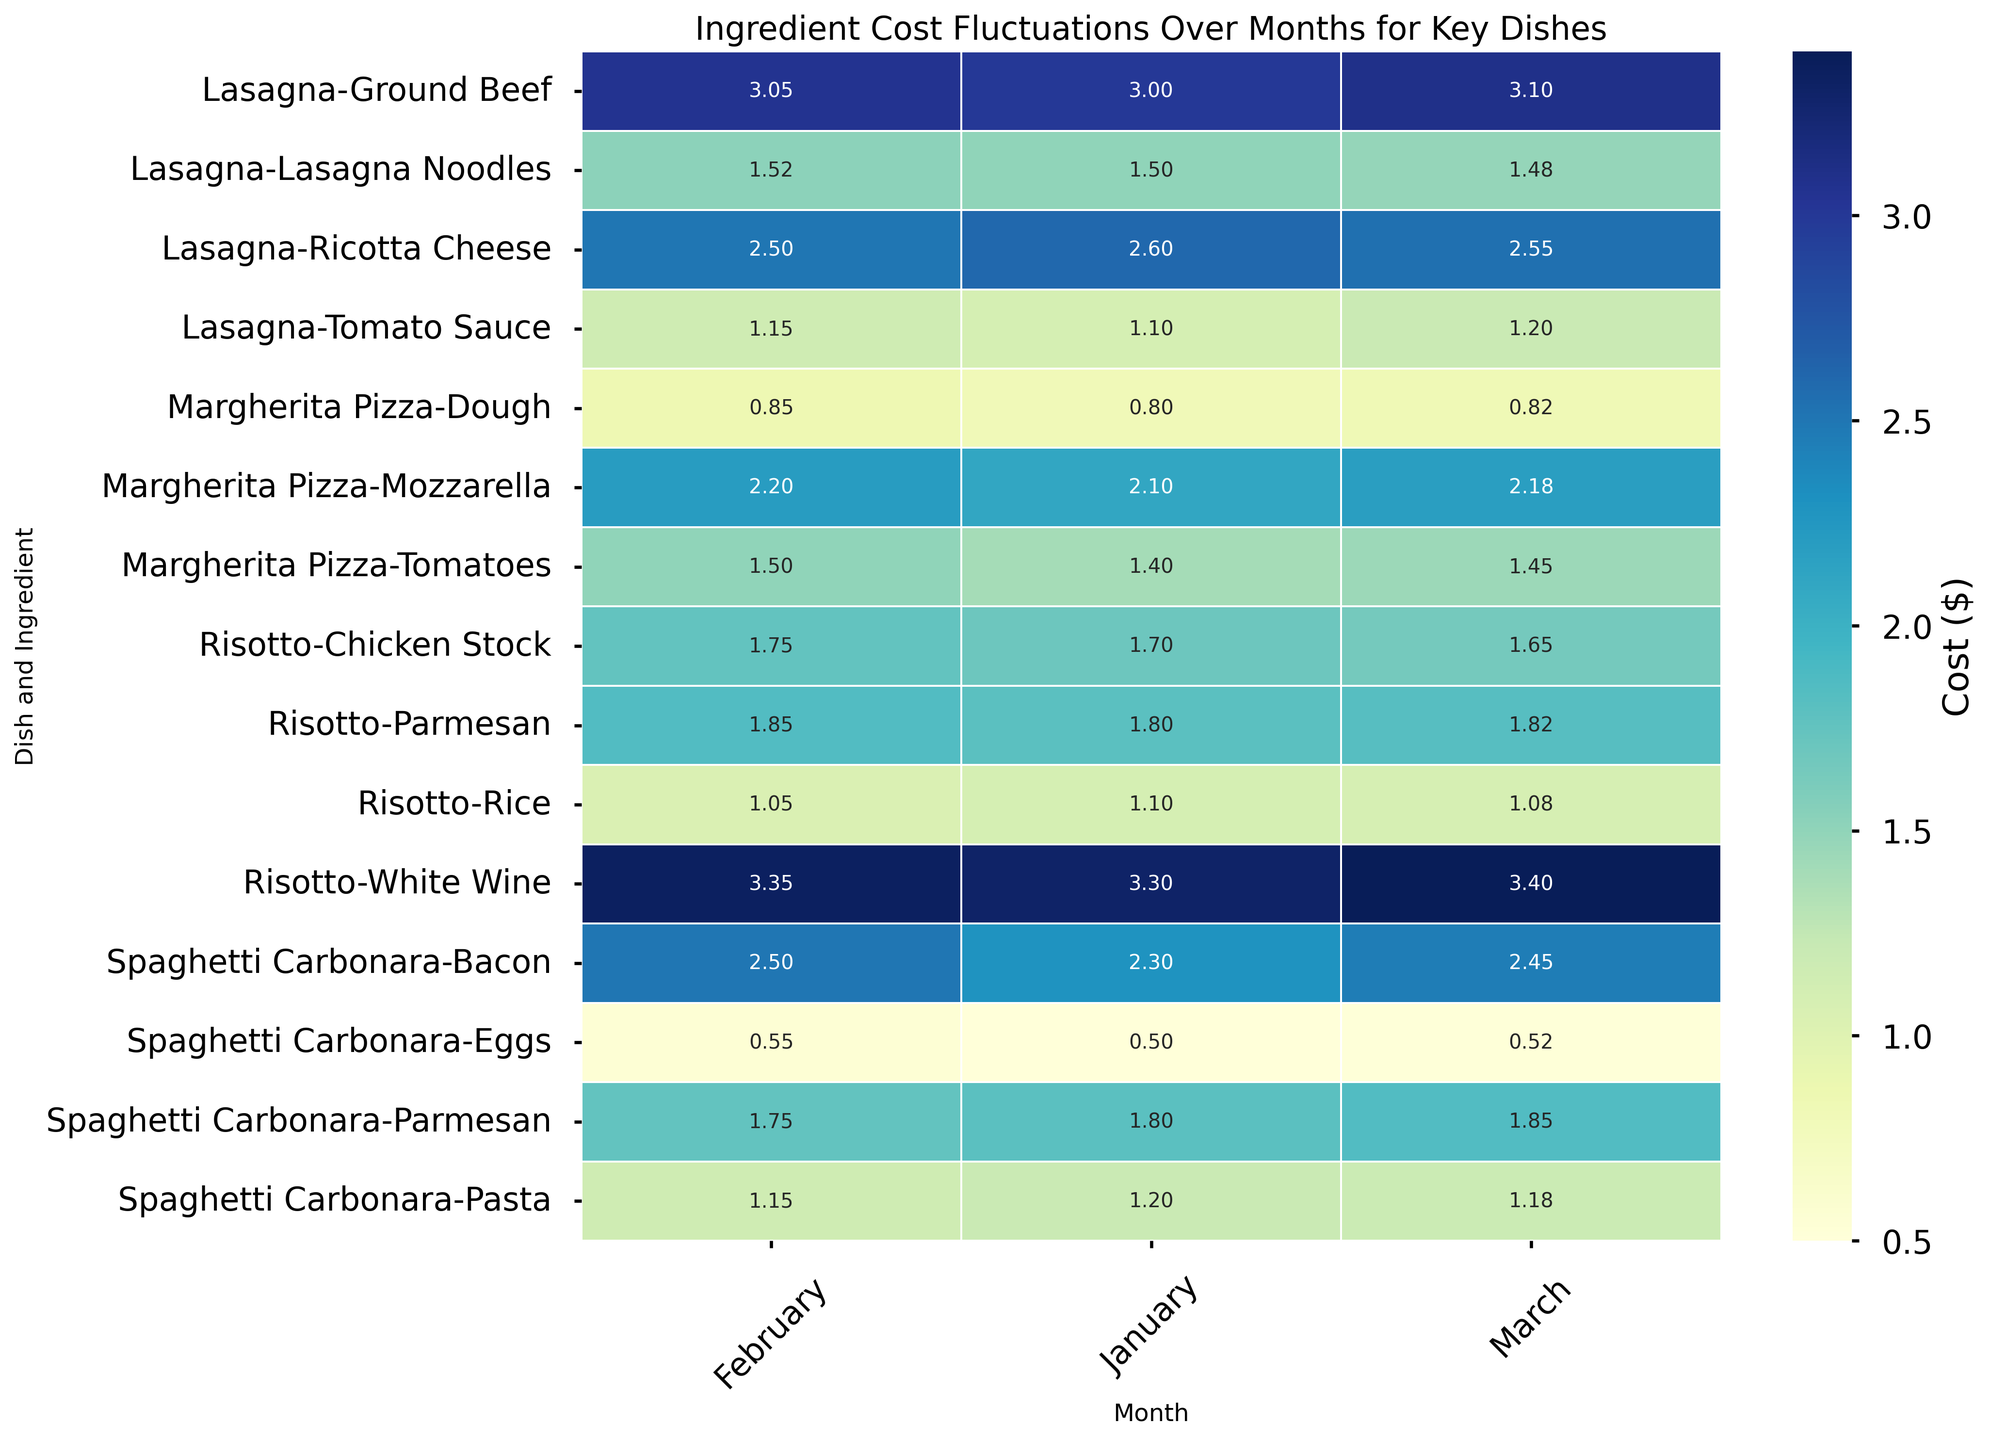What is the average cost of Bacon in Spaghetti Carbonara over the three months? To find the average cost of Bacon in Spaghetti Carbonara, first, look at the cost of Bacon in January, February, and March, which are 2.3, 2.5, and 2.45 respectively. Sum these costs: 2.3 + 2.5 + 2.45 = 7.25. Then, divide by 3 to find the average: 7.25 / 3 = 2.42.
Answer: 2.42 Which month had the highest cost for Ground Beef in Lasagna and what was the cost? Compare the cost of Ground Beef in Lasagna for the three months: 3.0 in January, 3.05 in February, and 3.1 in March. The highest cost is in March with 3.1.
Answer: March, 3.1 Did the cost of Parmesan in Spaghetti Carbonara increase or decrease from January to February? Identify the cost of Parmesan in January and February, which are 1.8 and 1.75 respectively. Since 1.75 is less than 1.8, the cost decreased.
Answer: Decrease What is the total cost of all ingredients for Risotto in February? Sum the costs of all the ingredients for Risotto in February: Rice (1.05), Chicken Stock (1.75), Parmesan (1.85), and White Wine (3.35). Therefore, the total cost is 1.05 + 1.75 + 1.85 + 3.35 = 8.00.
Answer: 8.00 Which ingredient in Margherita Pizza had the greatest fluctuation in cost over the three months? Examine the cost of each ingredient in Margherita Pizza over the three months: Dough (0.8, 0.85, 0.82), Tomatoes (1.4, 1.5, 1.45), and Mozzarella (2.1, 2.2, 2.18). Calculate the range (highest cost - lowest cost) for each: Dough (0.85 - 0.8 = 0.05), Tomatoes (1.5 - 1.4 = 0.1), and Mozzarella (2.2 - 2.1 = 0.1). Both Tomatoes and Mozzarella have the greatest fluctuation of 0.1.
Answer: Tomatoes and Mozzarella Did the cost of Lasagna Noodles in Lasagna decrease or increase from February to March? Identify the cost of Lasagna Noodles in February and March, which are 1.52 and 1.48 respectively. Since 1.48 is less than 1.52, the cost decreased.
Answer: Decrease What is the difference in cost between Rice in Risotto and Dough in Margherita Pizza for January? Identify the cost of Rice in Risotto for January (1.1) and Dough in Margherita Pizza for January (0.8). Subtract these values: 1.1 - 0.8 = 0.3.
Answer: 0.3 Which dish had the lowest total ingredient costs for January? Calculate the total ingredient costs for each dish in January: Spaghetti Carbonara (1.2 + 2.3 + 0.5 + 1.8 = 5.8), Margherita Pizza (0.8 + 1.4 + 2.1 = 4.3), Lasagna (1.5 + 3.0 + 1.1 + 2.6 = 8.2), and Risotto (1.1 + 1.7 + 1.8 + 3.3 = 7.9). Margherita Pizza has the lowest total ingredient cost of 4.3.
Answer: Margherita Pizza 